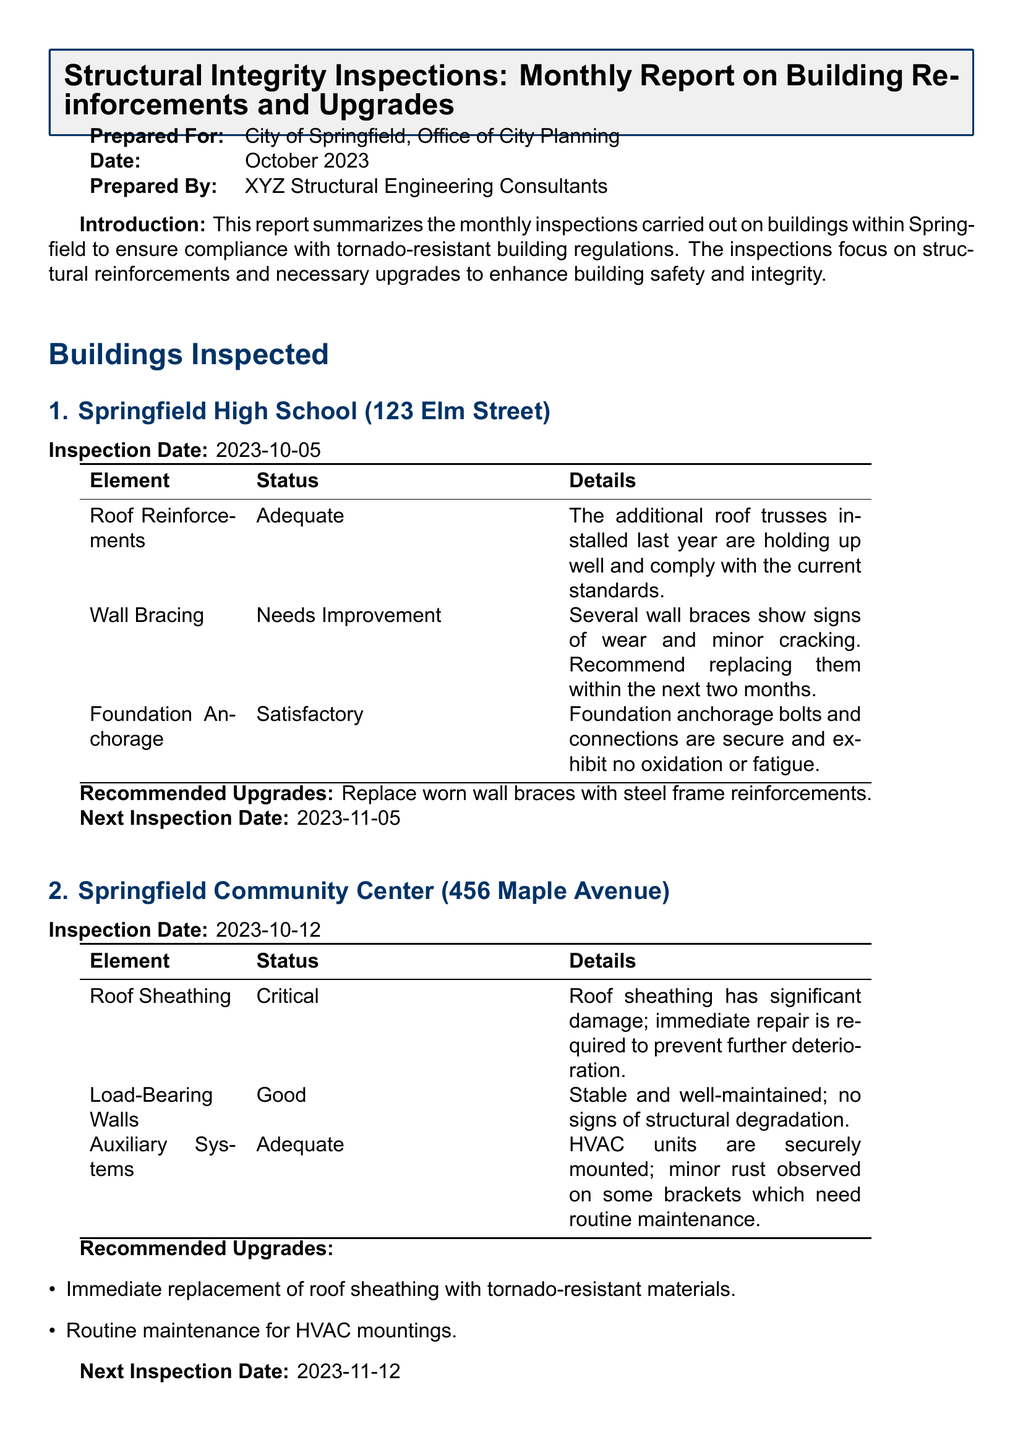What is the date of the report? The report is dated October 2023, as stated in the document header.
Answer: October 2023 What building requires immediate roof sheathing repair? The inspection details for the Springfield Community Center indicate significant damage to the roof sheathing requiring urgent attention.
Answer: Springfield Community Center When is the next inspection date for Springfield High School? The document states the next inspection date for Springfield High School is one month after the last inspection, scheduled for November 2023.
Answer: 2023-11-05 What is the status of the Load-Bearing Walls at the Community Center? The inspection report mentions that Load-Bearing Walls are in good condition with no signs of structural degradation.
Answer: Good What is recommended for the wall braces at Springfield High School? The report recommends replacing worn wall braces with steel frame reinforcements within the next two months.
Answer: Replace worn wall braces with steel frame reinforcements What deficiencies were noticed in the roof bracing at Springfield High School? The document specifies that several wall braces showed signs of wear and minor cracking, indicating a need for improvement.
Answer: Needs Improvement How many buildings were inspected as per the report? The report provides details on two buildings that were inspected for structural integrity.
Answer: Two buildings What does the Community Center’s auxiliary systems status indicate? The status indicates that auxiliary systems are adequate but have minor rust observed on some brackets needing routine maintenance.
Answer: Adequate 